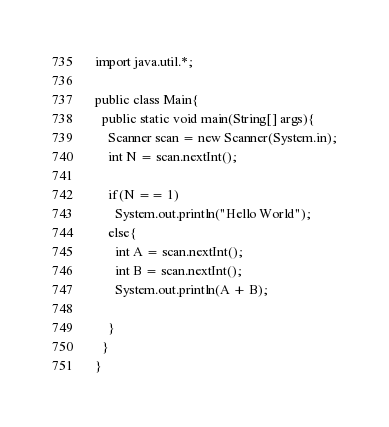Convert code to text. <code><loc_0><loc_0><loc_500><loc_500><_Java_>import java.util.*;

public class Main{
  public static void main(String[] args){
    Scanner scan = new Scanner(System.in);
    int N = scan.nextInt();

    if(N == 1)
      System.out.println("Hello World");
    else{
      int A = scan.nextInt();
      int B = scan.nextInt();
      System.out.println(A + B);

    }
  }
}
</code> 